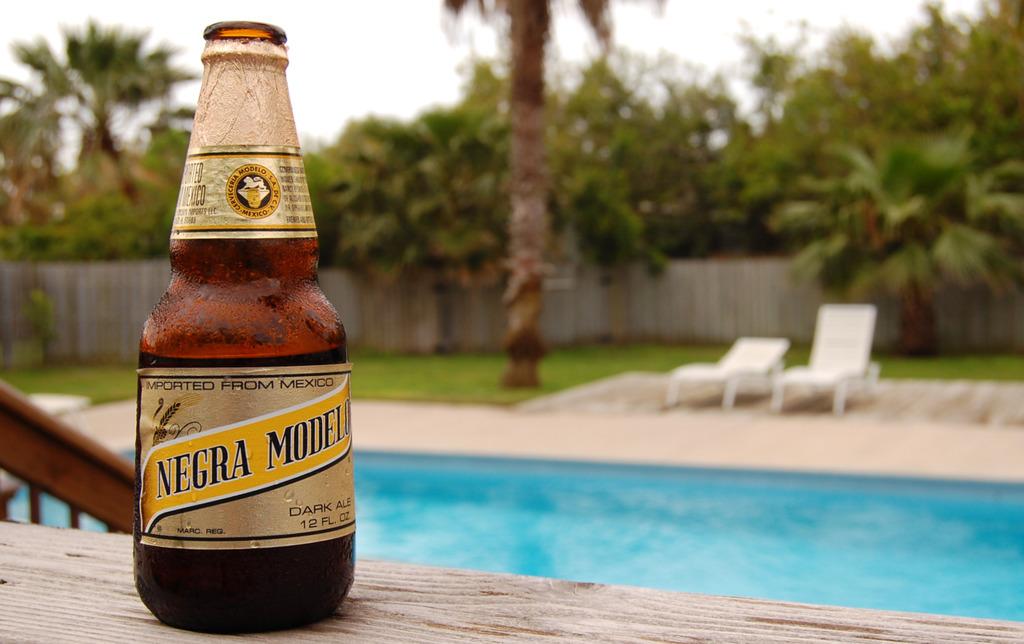What is the name of the beer?
Offer a terse response. Negra modelo. 